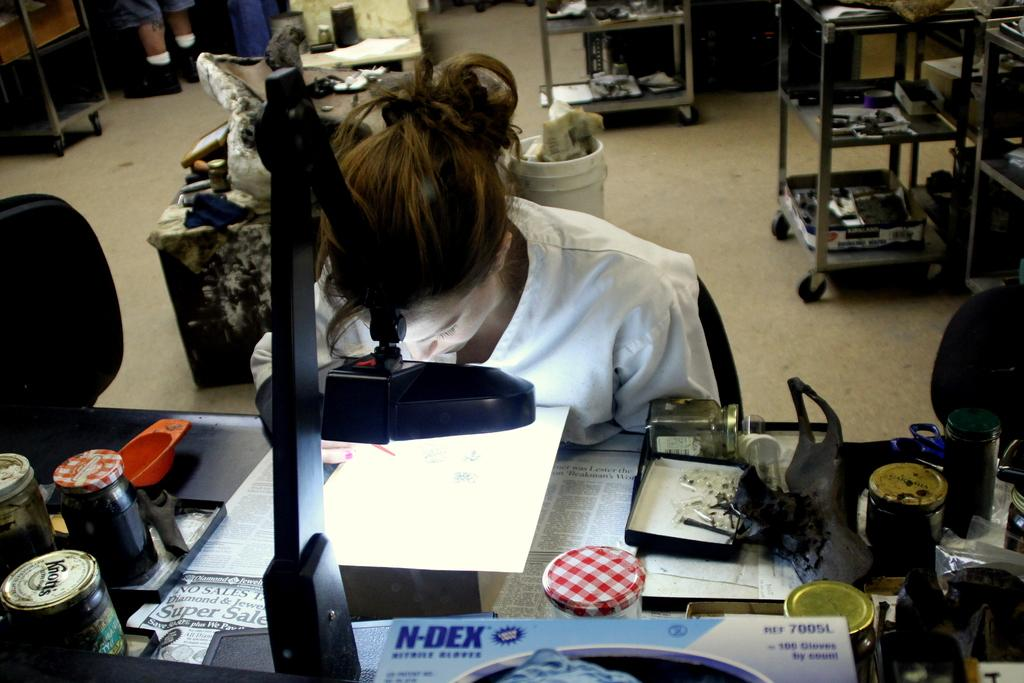<image>
Give a short and clear explanation of the subsequent image. A woman looking at a paer is surrounded by jars of Knott's and various other jellies. 